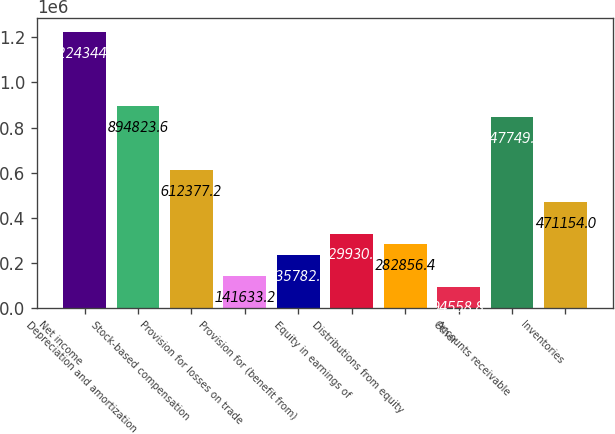Convert chart. <chart><loc_0><loc_0><loc_500><loc_500><bar_chart><fcel>Net income<fcel>Depreciation and amortization<fcel>Stock-based compensation<fcel>Provision for losses on trade<fcel>Provision for (benefit from)<fcel>Equity in earnings of<fcel>Distributions from equity<fcel>Other<fcel>Accounts receivable<fcel>Inventories<nl><fcel>1.22434e+06<fcel>894824<fcel>612377<fcel>141633<fcel>235782<fcel>329931<fcel>282856<fcel>94558.8<fcel>847749<fcel>471154<nl></chart> 